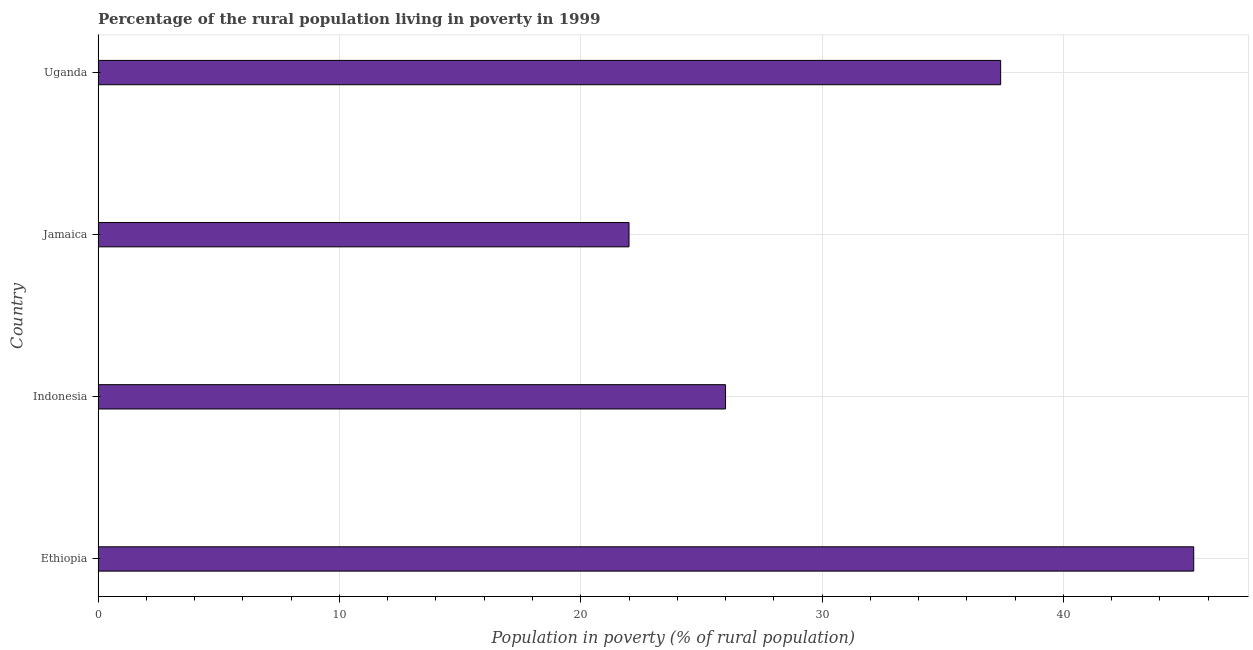What is the title of the graph?
Provide a short and direct response. Percentage of the rural population living in poverty in 1999. What is the label or title of the X-axis?
Provide a succinct answer. Population in poverty (% of rural population). What is the label or title of the Y-axis?
Your response must be concise. Country. Across all countries, what is the maximum percentage of rural population living below poverty line?
Provide a short and direct response. 45.4. Across all countries, what is the minimum percentage of rural population living below poverty line?
Provide a succinct answer. 22. In which country was the percentage of rural population living below poverty line maximum?
Keep it short and to the point. Ethiopia. In which country was the percentage of rural population living below poverty line minimum?
Your answer should be very brief. Jamaica. What is the sum of the percentage of rural population living below poverty line?
Provide a short and direct response. 130.8. What is the average percentage of rural population living below poverty line per country?
Ensure brevity in your answer.  32.7. What is the median percentage of rural population living below poverty line?
Offer a terse response. 31.7. What is the ratio of the percentage of rural population living below poverty line in Ethiopia to that in Uganda?
Provide a short and direct response. 1.21. Is the percentage of rural population living below poverty line in Indonesia less than that in Uganda?
Ensure brevity in your answer.  Yes. Is the difference between the percentage of rural population living below poverty line in Ethiopia and Jamaica greater than the difference between any two countries?
Provide a succinct answer. Yes. What is the difference between the highest and the lowest percentage of rural population living below poverty line?
Give a very brief answer. 23.4. In how many countries, is the percentage of rural population living below poverty line greater than the average percentage of rural population living below poverty line taken over all countries?
Offer a terse response. 2. How many bars are there?
Keep it short and to the point. 4. Are all the bars in the graph horizontal?
Offer a terse response. Yes. How many countries are there in the graph?
Provide a succinct answer. 4. What is the difference between two consecutive major ticks on the X-axis?
Your response must be concise. 10. What is the Population in poverty (% of rural population) in Ethiopia?
Provide a short and direct response. 45.4. What is the Population in poverty (% of rural population) in Indonesia?
Make the answer very short. 26. What is the Population in poverty (% of rural population) in Jamaica?
Keep it short and to the point. 22. What is the Population in poverty (% of rural population) of Uganda?
Your answer should be very brief. 37.4. What is the difference between the Population in poverty (% of rural population) in Ethiopia and Indonesia?
Your answer should be compact. 19.4. What is the difference between the Population in poverty (% of rural population) in Ethiopia and Jamaica?
Ensure brevity in your answer.  23.4. What is the difference between the Population in poverty (% of rural population) in Indonesia and Jamaica?
Provide a succinct answer. 4. What is the difference between the Population in poverty (% of rural population) in Indonesia and Uganda?
Your answer should be compact. -11.4. What is the difference between the Population in poverty (% of rural population) in Jamaica and Uganda?
Offer a very short reply. -15.4. What is the ratio of the Population in poverty (% of rural population) in Ethiopia to that in Indonesia?
Ensure brevity in your answer.  1.75. What is the ratio of the Population in poverty (% of rural population) in Ethiopia to that in Jamaica?
Your response must be concise. 2.06. What is the ratio of the Population in poverty (% of rural population) in Ethiopia to that in Uganda?
Offer a very short reply. 1.21. What is the ratio of the Population in poverty (% of rural population) in Indonesia to that in Jamaica?
Provide a short and direct response. 1.18. What is the ratio of the Population in poverty (% of rural population) in Indonesia to that in Uganda?
Give a very brief answer. 0.69. What is the ratio of the Population in poverty (% of rural population) in Jamaica to that in Uganda?
Your answer should be compact. 0.59. 